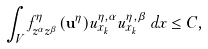<formula> <loc_0><loc_0><loc_500><loc_500>\int _ { V } f ^ { \eta } _ { z ^ { \alpha } z ^ { \beta } } ( \mathbf u ^ { \eta } ) u ^ { \eta , \alpha } _ { x _ { k } } u ^ { \eta , \beta } _ { x _ { k } } \, d x \leq C ,</formula> 